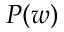Convert formula to latex. <formula><loc_0><loc_0><loc_500><loc_500>P ( w )</formula> 